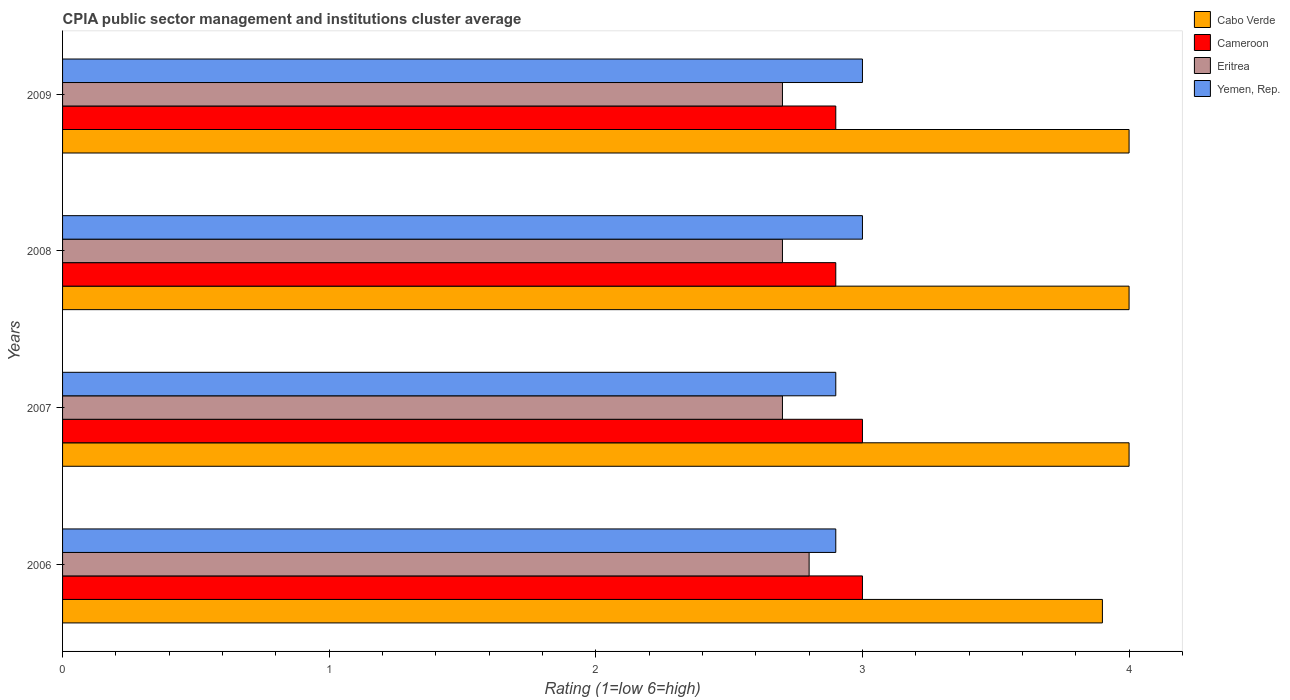How many groups of bars are there?
Offer a very short reply. 4. Are the number of bars on each tick of the Y-axis equal?
Keep it short and to the point. Yes. Across all years, what is the maximum CPIA rating in Eritrea?
Offer a terse response. 2.8. In which year was the CPIA rating in Yemen, Rep. maximum?
Ensure brevity in your answer.  2008. What is the difference between the CPIA rating in Eritrea in 2007 and that in 2009?
Keep it short and to the point. 0. What is the difference between the CPIA rating in Yemen, Rep. in 2006 and the CPIA rating in Eritrea in 2008?
Offer a very short reply. 0.2. What is the average CPIA rating in Cameroon per year?
Make the answer very short. 2.95. In the year 2006, what is the difference between the CPIA rating in Cabo Verde and CPIA rating in Yemen, Rep.?
Give a very brief answer. 1. What is the difference between the highest and the second highest CPIA rating in Eritrea?
Offer a very short reply. 0.1. What is the difference between the highest and the lowest CPIA rating in Eritrea?
Ensure brevity in your answer.  0.1. Is the sum of the CPIA rating in Yemen, Rep. in 2007 and 2008 greater than the maximum CPIA rating in Cameroon across all years?
Give a very brief answer. Yes. What does the 4th bar from the top in 2008 represents?
Make the answer very short. Cabo Verde. What does the 2nd bar from the bottom in 2009 represents?
Provide a short and direct response. Cameroon. Is it the case that in every year, the sum of the CPIA rating in Cabo Verde and CPIA rating in Cameroon is greater than the CPIA rating in Yemen, Rep.?
Your answer should be very brief. Yes. Are all the bars in the graph horizontal?
Provide a short and direct response. Yes. Are the values on the major ticks of X-axis written in scientific E-notation?
Your answer should be compact. No. Does the graph contain grids?
Ensure brevity in your answer.  No. What is the title of the graph?
Your response must be concise. CPIA public sector management and institutions cluster average. What is the Rating (1=low 6=high) in Cameroon in 2006?
Offer a very short reply. 3. What is the Rating (1=low 6=high) of Eritrea in 2006?
Make the answer very short. 2.8. What is the Rating (1=low 6=high) in Yemen, Rep. in 2006?
Your response must be concise. 2.9. What is the Rating (1=low 6=high) in Cabo Verde in 2007?
Your response must be concise. 4. What is the Rating (1=low 6=high) in Cameroon in 2007?
Your answer should be compact. 3. What is the Rating (1=low 6=high) of Yemen, Rep. in 2007?
Your answer should be compact. 2.9. What is the Rating (1=low 6=high) of Eritrea in 2008?
Keep it short and to the point. 2.7. What is the Rating (1=low 6=high) in Yemen, Rep. in 2008?
Offer a terse response. 3. What is the Rating (1=low 6=high) in Cabo Verde in 2009?
Provide a succinct answer. 4. What is the Rating (1=low 6=high) of Eritrea in 2009?
Keep it short and to the point. 2.7. Across all years, what is the maximum Rating (1=low 6=high) in Cabo Verde?
Make the answer very short. 4. Across all years, what is the maximum Rating (1=low 6=high) in Eritrea?
Keep it short and to the point. 2.8. Across all years, what is the maximum Rating (1=low 6=high) in Yemen, Rep.?
Ensure brevity in your answer.  3. Across all years, what is the minimum Rating (1=low 6=high) of Cabo Verde?
Your answer should be very brief. 3.9. Across all years, what is the minimum Rating (1=low 6=high) of Yemen, Rep.?
Give a very brief answer. 2.9. What is the total Rating (1=low 6=high) in Eritrea in the graph?
Make the answer very short. 10.9. What is the difference between the Rating (1=low 6=high) in Cabo Verde in 2006 and that in 2007?
Ensure brevity in your answer.  -0.1. What is the difference between the Rating (1=low 6=high) of Cameroon in 2006 and that in 2007?
Make the answer very short. 0. What is the difference between the Rating (1=low 6=high) of Yemen, Rep. in 2006 and that in 2007?
Provide a short and direct response. 0. What is the difference between the Rating (1=low 6=high) of Cabo Verde in 2006 and that in 2008?
Keep it short and to the point. -0.1. What is the difference between the Rating (1=low 6=high) of Cabo Verde in 2006 and that in 2009?
Your response must be concise. -0.1. What is the difference between the Rating (1=low 6=high) of Eritrea in 2006 and that in 2009?
Your answer should be very brief. 0.1. What is the difference between the Rating (1=low 6=high) in Yemen, Rep. in 2006 and that in 2009?
Provide a succinct answer. -0.1. What is the difference between the Rating (1=low 6=high) in Cabo Verde in 2007 and that in 2008?
Offer a terse response. 0. What is the difference between the Rating (1=low 6=high) in Cameroon in 2007 and that in 2008?
Your answer should be compact. 0.1. What is the difference between the Rating (1=low 6=high) in Eritrea in 2007 and that in 2008?
Offer a very short reply. 0. What is the difference between the Rating (1=low 6=high) of Cabo Verde in 2007 and that in 2009?
Offer a terse response. 0. What is the difference between the Rating (1=low 6=high) of Cameroon in 2007 and that in 2009?
Provide a succinct answer. 0.1. What is the difference between the Rating (1=low 6=high) of Eritrea in 2007 and that in 2009?
Provide a succinct answer. 0. What is the difference between the Rating (1=low 6=high) in Yemen, Rep. in 2007 and that in 2009?
Your response must be concise. -0.1. What is the difference between the Rating (1=low 6=high) in Cabo Verde in 2008 and that in 2009?
Keep it short and to the point. 0. What is the difference between the Rating (1=low 6=high) in Cameroon in 2008 and that in 2009?
Keep it short and to the point. 0. What is the difference between the Rating (1=low 6=high) of Cabo Verde in 2006 and the Rating (1=low 6=high) of Cameroon in 2007?
Your answer should be very brief. 0.9. What is the difference between the Rating (1=low 6=high) of Cabo Verde in 2006 and the Rating (1=low 6=high) of Yemen, Rep. in 2007?
Give a very brief answer. 1. What is the difference between the Rating (1=low 6=high) of Cameroon in 2006 and the Rating (1=low 6=high) of Eritrea in 2007?
Offer a very short reply. 0.3. What is the difference between the Rating (1=low 6=high) of Cameroon in 2006 and the Rating (1=low 6=high) of Yemen, Rep. in 2007?
Your answer should be compact. 0.1. What is the difference between the Rating (1=low 6=high) of Cabo Verde in 2006 and the Rating (1=low 6=high) of Eritrea in 2008?
Make the answer very short. 1.2. What is the difference between the Rating (1=low 6=high) in Cameroon in 2006 and the Rating (1=low 6=high) in Eritrea in 2008?
Offer a terse response. 0.3. What is the difference between the Rating (1=low 6=high) of Eritrea in 2006 and the Rating (1=low 6=high) of Yemen, Rep. in 2008?
Your answer should be compact. -0.2. What is the difference between the Rating (1=low 6=high) in Cabo Verde in 2006 and the Rating (1=low 6=high) in Cameroon in 2009?
Provide a succinct answer. 1. What is the difference between the Rating (1=low 6=high) in Cameroon in 2006 and the Rating (1=low 6=high) in Yemen, Rep. in 2009?
Provide a succinct answer. 0. What is the difference between the Rating (1=low 6=high) of Cabo Verde in 2007 and the Rating (1=low 6=high) of Cameroon in 2008?
Provide a short and direct response. 1.1. What is the difference between the Rating (1=low 6=high) of Cabo Verde in 2007 and the Rating (1=low 6=high) of Eritrea in 2008?
Provide a short and direct response. 1.3. What is the difference between the Rating (1=low 6=high) of Eritrea in 2007 and the Rating (1=low 6=high) of Yemen, Rep. in 2008?
Your answer should be compact. -0.3. What is the difference between the Rating (1=low 6=high) of Cameroon in 2007 and the Rating (1=low 6=high) of Eritrea in 2009?
Your response must be concise. 0.3. What is the difference between the Rating (1=low 6=high) in Cameroon in 2007 and the Rating (1=low 6=high) in Yemen, Rep. in 2009?
Offer a terse response. 0. What is the difference between the Rating (1=low 6=high) in Cabo Verde in 2008 and the Rating (1=low 6=high) in Cameroon in 2009?
Offer a terse response. 1.1. What is the difference between the Rating (1=low 6=high) in Cabo Verde in 2008 and the Rating (1=low 6=high) in Yemen, Rep. in 2009?
Provide a short and direct response. 1. What is the difference between the Rating (1=low 6=high) in Cameroon in 2008 and the Rating (1=low 6=high) in Eritrea in 2009?
Provide a succinct answer. 0.2. What is the difference between the Rating (1=low 6=high) of Cameroon in 2008 and the Rating (1=low 6=high) of Yemen, Rep. in 2009?
Give a very brief answer. -0.1. What is the difference between the Rating (1=low 6=high) in Eritrea in 2008 and the Rating (1=low 6=high) in Yemen, Rep. in 2009?
Your response must be concise. -0.3. What is the average Rating (1=low 6=high) in Cabo Verde per year?
Make the answer very short. 3.98. What is the average Rating (1=low 6=high) in Cameroon per year?
Your answer should be compact. 2.95. What is the average Rating (1=low 6=high) in Eritrea per year?
Your answer should be very brief. 2.73. What is the average Rating (1=low 6=high) of Yemen, Rep. per year?
Provide a short and direct response. 2.95. In the year 2006, what is the difference between the Rating (1=low 6=high) in Cabo Verde and Rating (1=low 6=high) in Yemen, Rep.?
Ensure brevity in your answer.  1. In the year 2006, what is the difference between the Rating (1=low 6=high) of Cameroon and Rating (1=low 6=high) of Eritrea?
Your answer should be compact. 0.2. In the year 2007, what is the difference between the Rating (1=low 6=high) of Cabo Verde and Rating (1=low 6=high) of Eritrea?
Make the answer very short. 1.3. In the year 2007, what is the difference between the Rating (1=low 6=high) of Eritrea and Rating (1=low 6=high) of Yemen, Rep.?
Your answer should be very brief. -0.2. In the year 2008, what is the difference between the Rating (1=low 6=high) in Cabo Verde and Rating (1=low 6=high) in Eritrea?
Offer a terse response. 1.3. In the year 2008, what is the difference between the Rating (1=low 6=high) in Cameroon and Rating (1=low 6=high) in Eritrea?
Your answer should be very brief. 0.2. In the year 2008, what is the difference between the Rating (1=low 6=high) of Eritrea and Rating (1=low 6=high) of Yemen, Rep.?
Keep it short and to the point. -0.3. In the year 2009, what is the difference between the Rating (1=low 6=high) of Cabo Verde and Rating (1=low 6=high) of Cameroon?
Keep it short and to the point. 1.1. What is the ratio of the Rating (1=low 6=high) of Cabo Verde in 2006 to that in 2008?
Provide a short and direct response. 0.97. What is the ratio of the Rating (1=low 6=high) in Cameroon in 2006 to that in 2008?
Your response must be concise. 1.03. What is the ratio of the Rating (1=low 6=high) in Yemen, Rep. in 2006 to that in 2008?
Make the answer very short. 0.97. What is the ratio of the Rating (1=low 6=high) in Cameroon in 2006 to that in 2009?
Keep it short and to the point. 1.03. What is the ratio of the Rating (1=low 6=high) of Eritrea in 2006 to that in 2009?
Provide a succinct answer. 1.04. What is the ratio of the Rating (1=low 6=high) in Yemen, Rep. in 2006 to that in 2009?
Your answer should be very brief. 0.97. What is the ratio of the Rating (1=low 6=high) in Cameroon in 2007 to that in 2008?
Offer a terse response. 1.03. What is the ratio of the Rating (1=low 6=high) of Eritrea in 2007 to that in 2008?
Your answer should be very brief. 1. What is the ratio of the Rating (1=low 6=high) in Yemen, Rep. in 2007 to that in 2008?
Your response must be concise. 0.97. What is the ratio of the Rating (1=low 6=high) of Cameroon in 2007 to that in 2009?
Offer a terse response. 1.03. What is the ratio of the Rating (1=low 6=high) in Yemen, Rep. in 2007 to that in 2009?
Your answer should be compact. 0.97. What is the ratio of the Rating (1=low 6=high) of Cabo Verde in 2008 to that in 2009?
Keep it short and to the point. 1. What is the ratio of the Rating (1=low 6=high) in Cameroon in 2008 to that in 2009?
Provide a succinct answer. 1. What is the ratio of the Rating (1=low 6=high) of Yemen, Rep. in 2008 to that in 2009?
Your response must be concise. 1. What is the difference between the highest and the second highest Rating (1=low 6=high) in Cabo Verde?
Your answer should be compact. 0. What is the difference between the highest and the second highest Rating (1=low 6=high) in Cameroon?
Keep it short and to the point. 0. What is the difference between the highest and the lowest Rating (1=low 6=high) of Cameroon?
Your response must be concise. 0.1. What is the difference between the highest and the lowest Rating (1=low 6=high) of Eritrea?
Offer a terse response. 0.1. What is the difference between the highest and the lowest Rating (1=low 6=high) of Yemen, Rep.?
Your answer should be very brief. 0.1. 